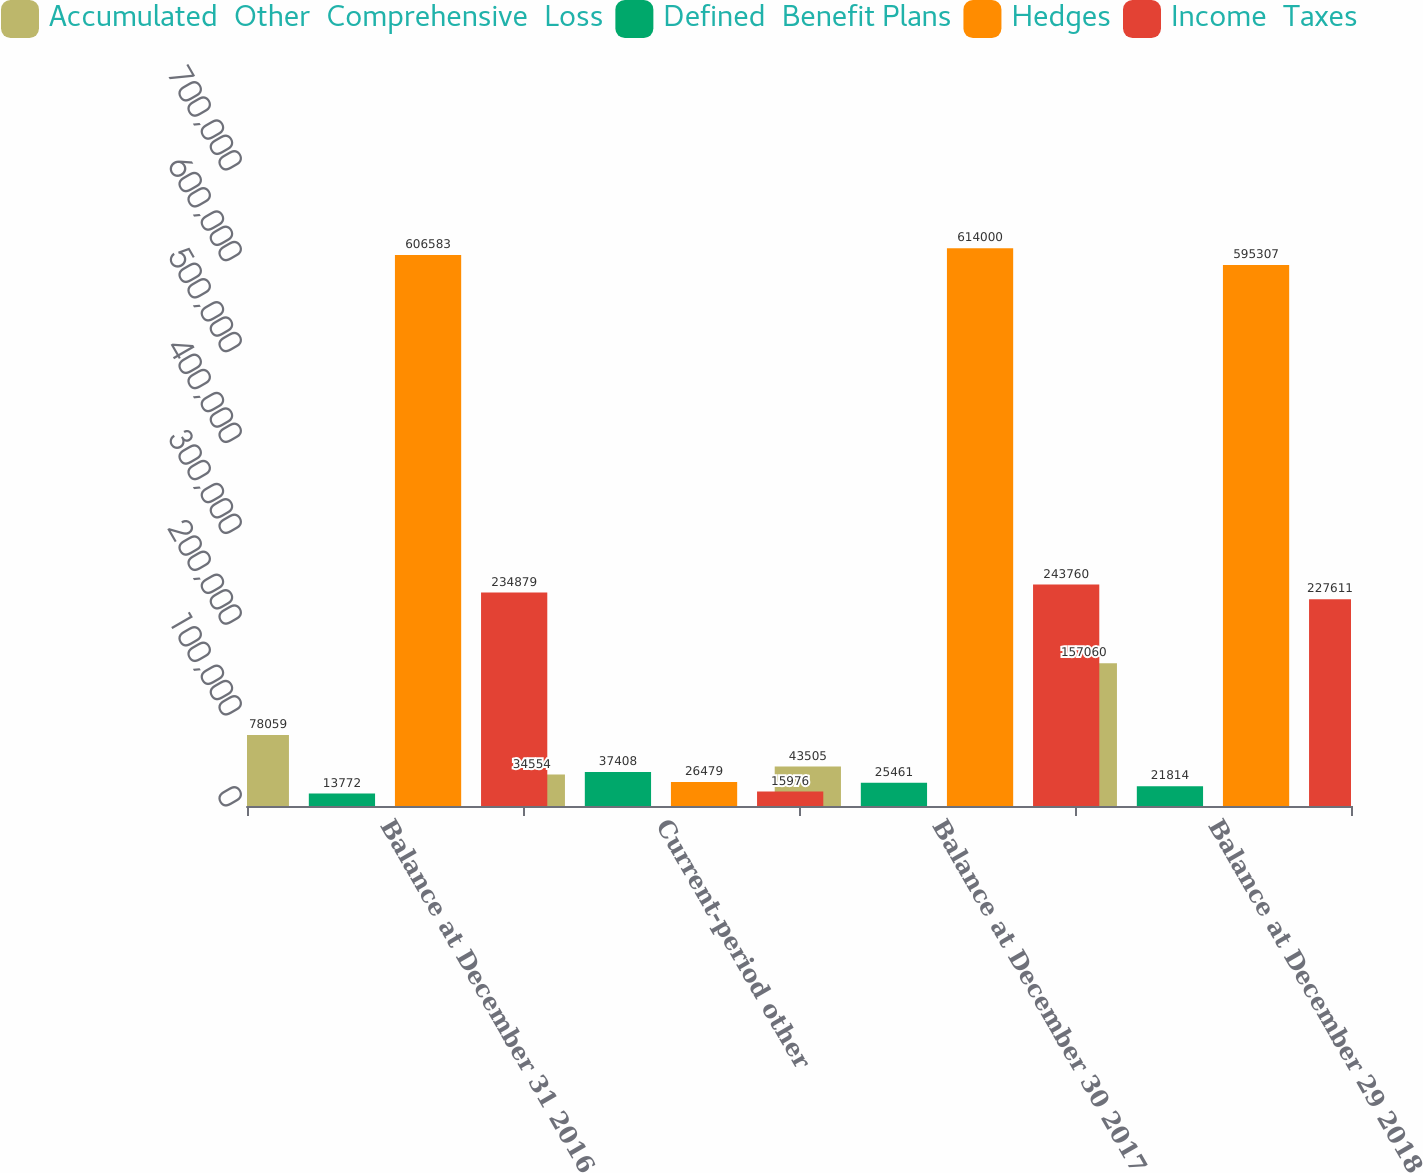Convert chart. <chart><loc_0><loc_0><loc_500><loc_500><stacked_bar_chart><ecel><fcel>Balance at December 31 2016<fcel>Current-period other<fcel>Balance at December 30 2017<fcel>Balance at December 29 2018<nl><fcel>Accumulated  Other  Comprehensive  Loss<fcel>78059<fcel>34554<fcel>43505<fcel>157060<nl><fcel>Defined  Benefit Plans<fcel>13772<fcel>37408<fcel>25461<fcel>21814<nl><fcel>Hedges<fcel>606583<fcel>26479<fcel>614000<fcel>595307<nl><fcel>Income  Taxes<fcel>234879<fcel>15976<fcel>243760<fcel>227611<nl></chart> 